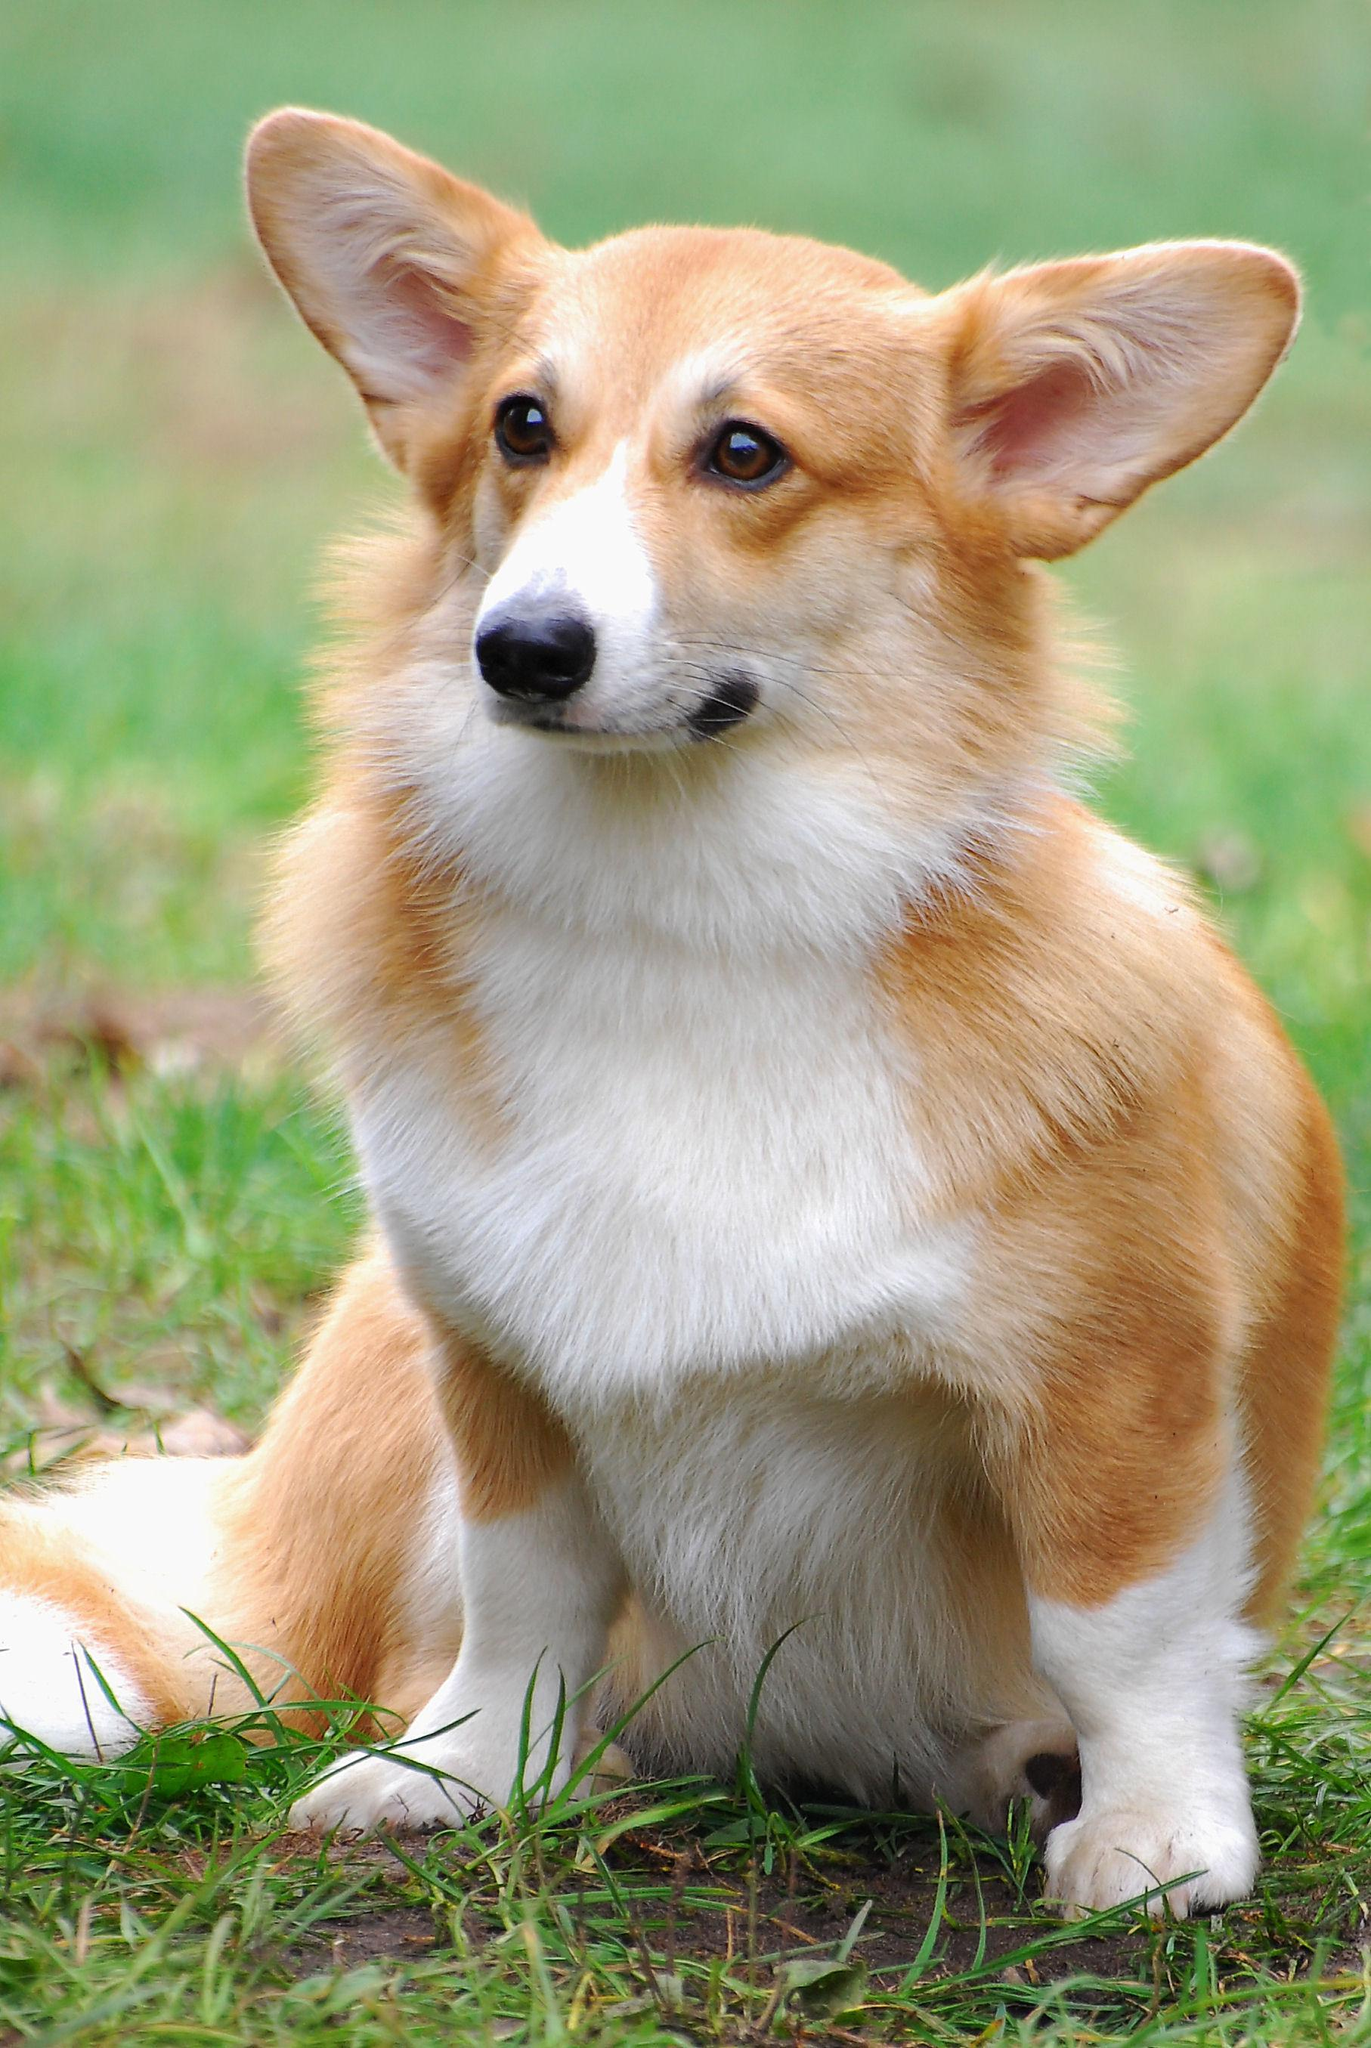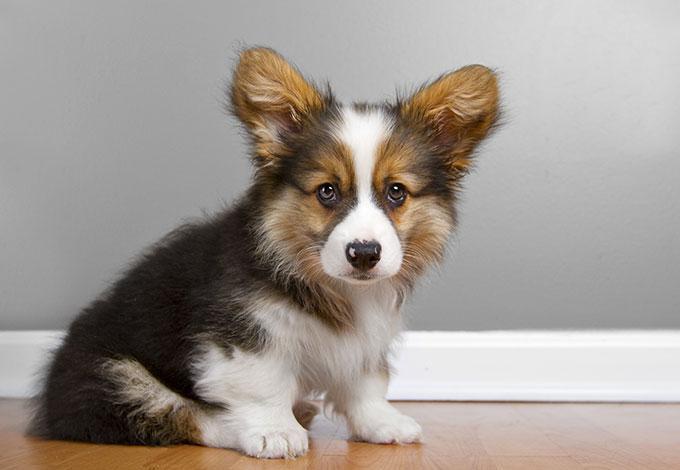The first image is the image on the left, the second image is the image on the right. Evaluate the accuracy of this statement regarding the images: "At least one dog is sitting.". Is it true? Answer yes or no. Yes. 